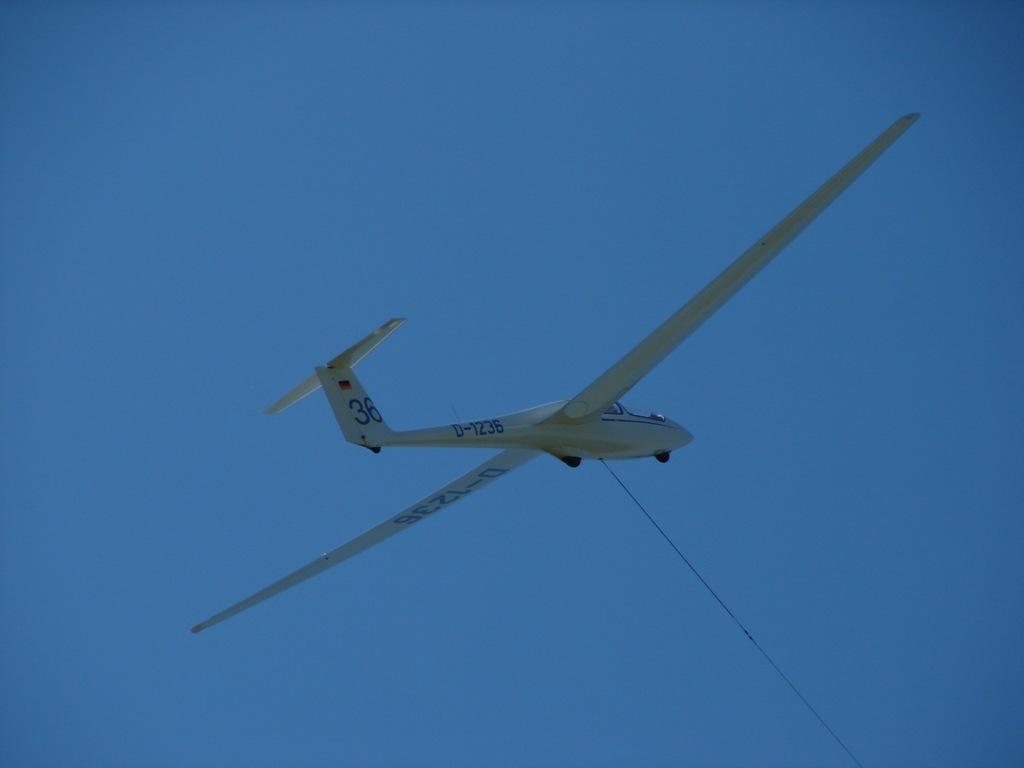Describe this image in one or two sentences. In this picture, we can see a plane with a rope attached to it and we can see the sky. 